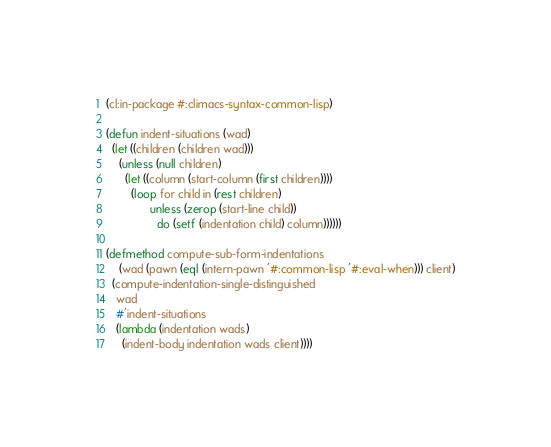<code> <loc_0><loc_0><loc_500><loc_500><_Lisp_>(cl:in-package #:climacs-syntax-common-lisp)

(defun indent-situations (wad)
  (let ((children (children wad)))
    (unless (null children)
      (let ((column (start-column (first children))))
        (loop for child in (rest children)
              unless (zerop (start-line child))
                do (setf (indentation child) column))))))

(defmethod compute-sub-form-indentations
    (wad (pawn (eql (intern-pawn '#:common-lisp '#:eval-when))) client)
  (compute-indentation-single-distinguished
   wad
   #'indent-situations
   (lambda (indentation wads)
     (indent-body indentation wads client))))
</code> 